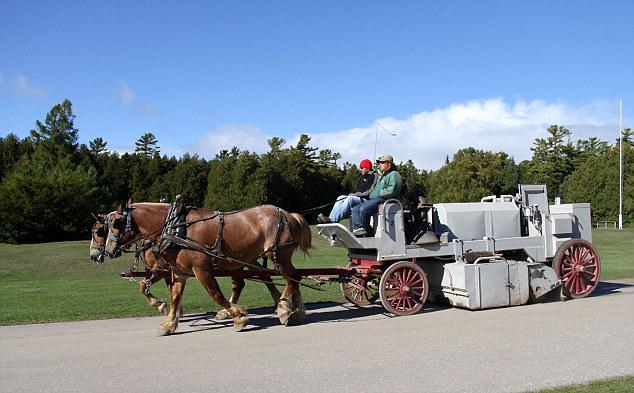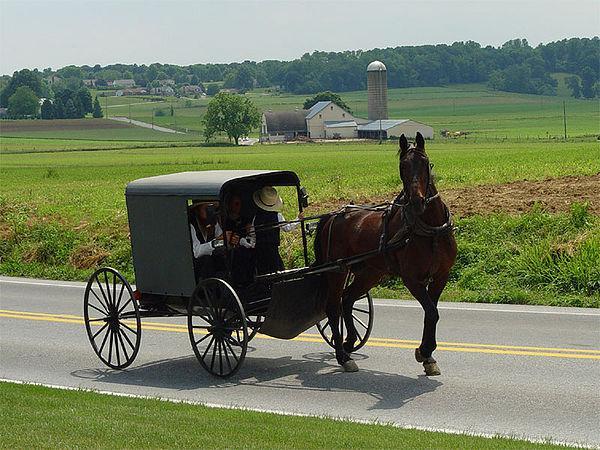The first image is the image on the left, the second image is the image on the right. For the images shown, is this caption "There are no less than three animals pulling something on wheels." true? Answer yes or no. Yes. The first image is the image on the left, the second image is the image on the right. Given the left and right images, does the statement "the right side pics has a four wheel wagon moving to the right" hold true? Answer yes or no. Yes. 